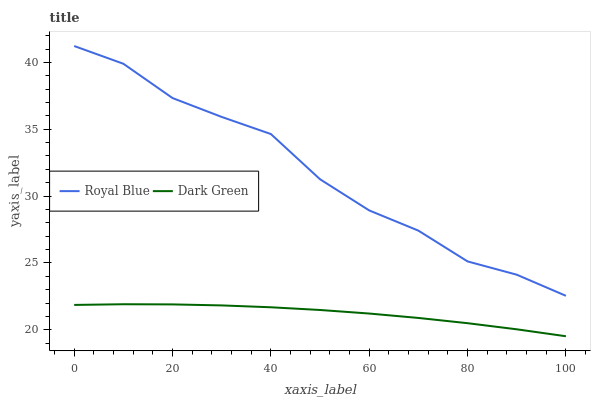Does Dark Green have the minimum area under the curve?
Answer yes or no. Yes. Does Royal Blue have the maximum area under the curve?
Answer yes or no. Yes. Does Dark Green have the maximum area under the curve?
Answer yes or no. No. Is Dark Green the smoothest?
Answer yes or no. Yes. Is Royal Blue the roughest?
Answer yes or no. Yes. Is Dark Green the roughest?
Answer yes or no. No. Does Dark Green have the lowest value?
Answer yes or no. Yes. Does Royal Blue have the highest value?
Answer yes or no. Yes. Does Dark Green have the highest value?
Answer yes or no. No. Is Dark Green less than Royal Blue?
Answer yes or no. Yes. Is Royal Blue greater than Dark Green?
Answer yes or no. Yes. Does Dark Green intersect Royal Blue?
Answer yes or no. No. 